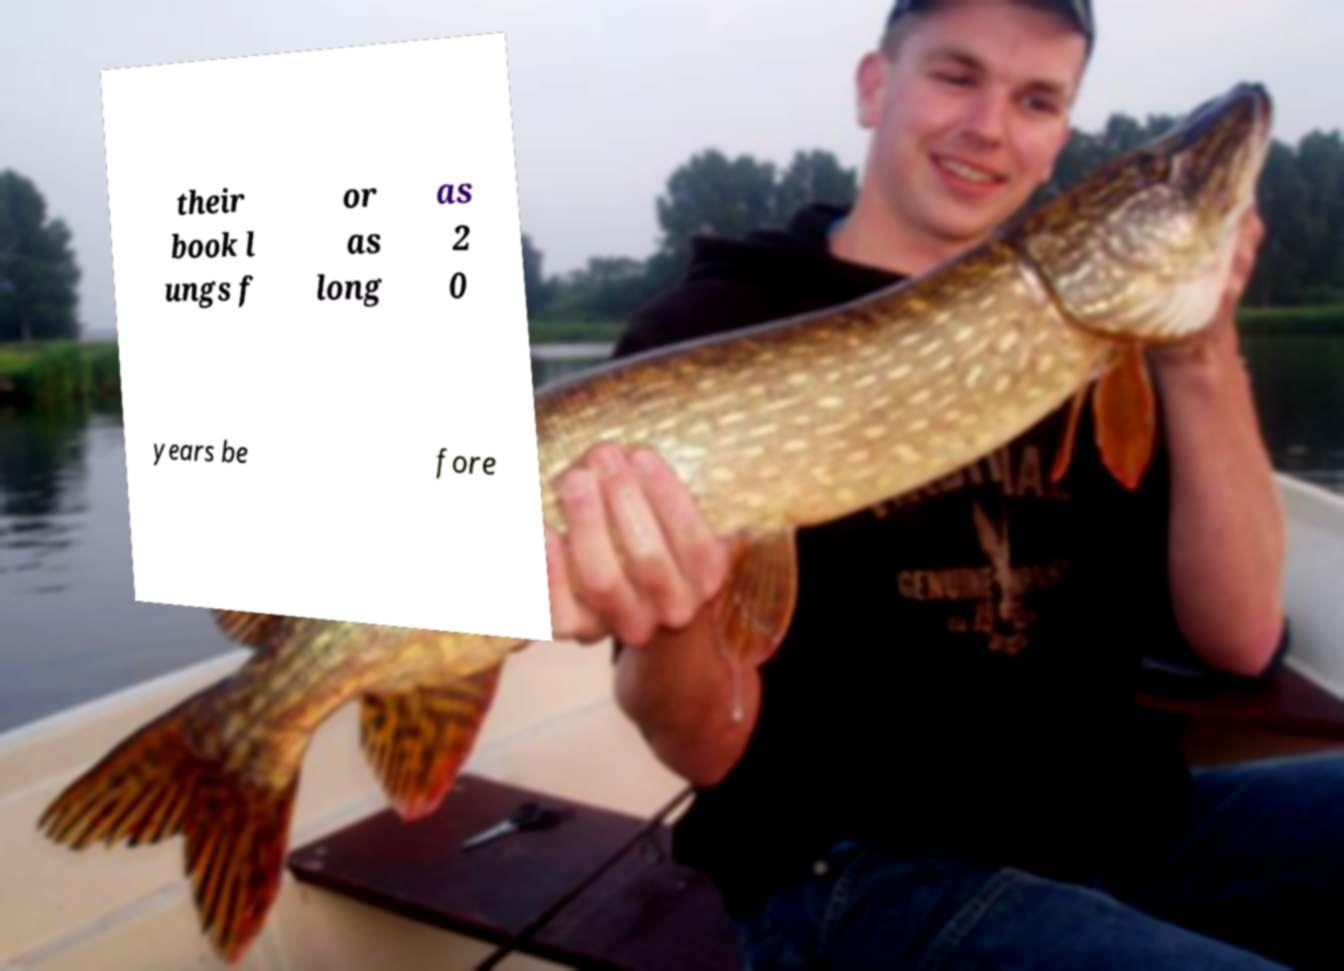Could you assist in decoding the text presented in this image and type it out clearly? their book l ungs f or as long as 2 0 years be fore 